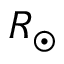<formula> <loc_0><loc_0><loc_500><loc_500>R _ { \odot }</formula> 